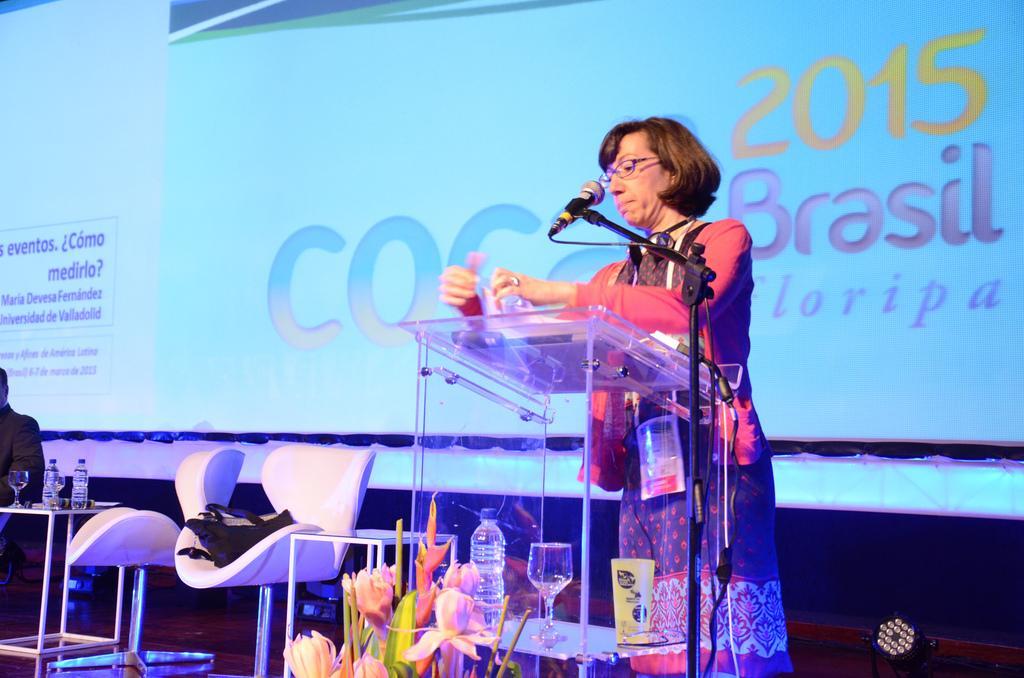In one or two sentences, can you explain what this image depicts? In this image I can see the person standing in-front of the podium and mic. I can also see the bottle, glass, board and the flowers. To the side of the person I can see the chair and one more person sitting in-front of the table. On the table I can see the bottles and glasses. In the background I can see the screen. 